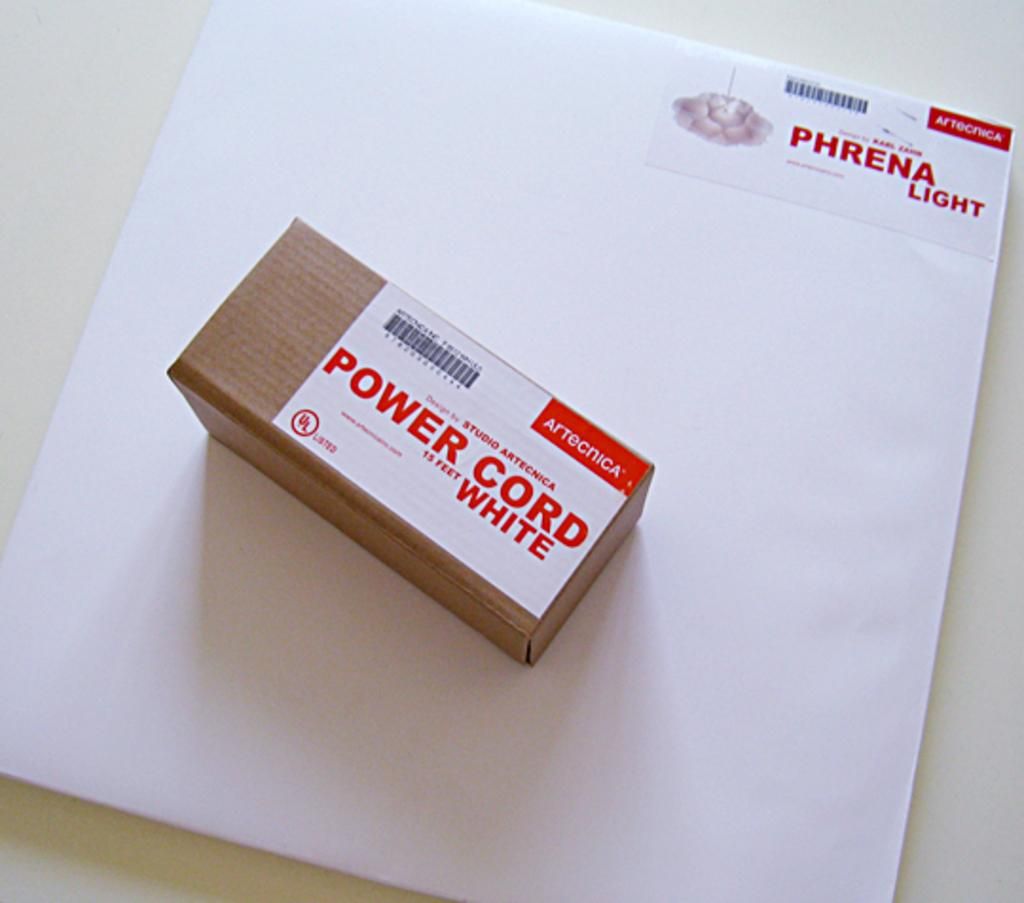<image>
Share a concise interpretation of the image provided. Box laying with Power Cord 13 feet white written in red letters. 